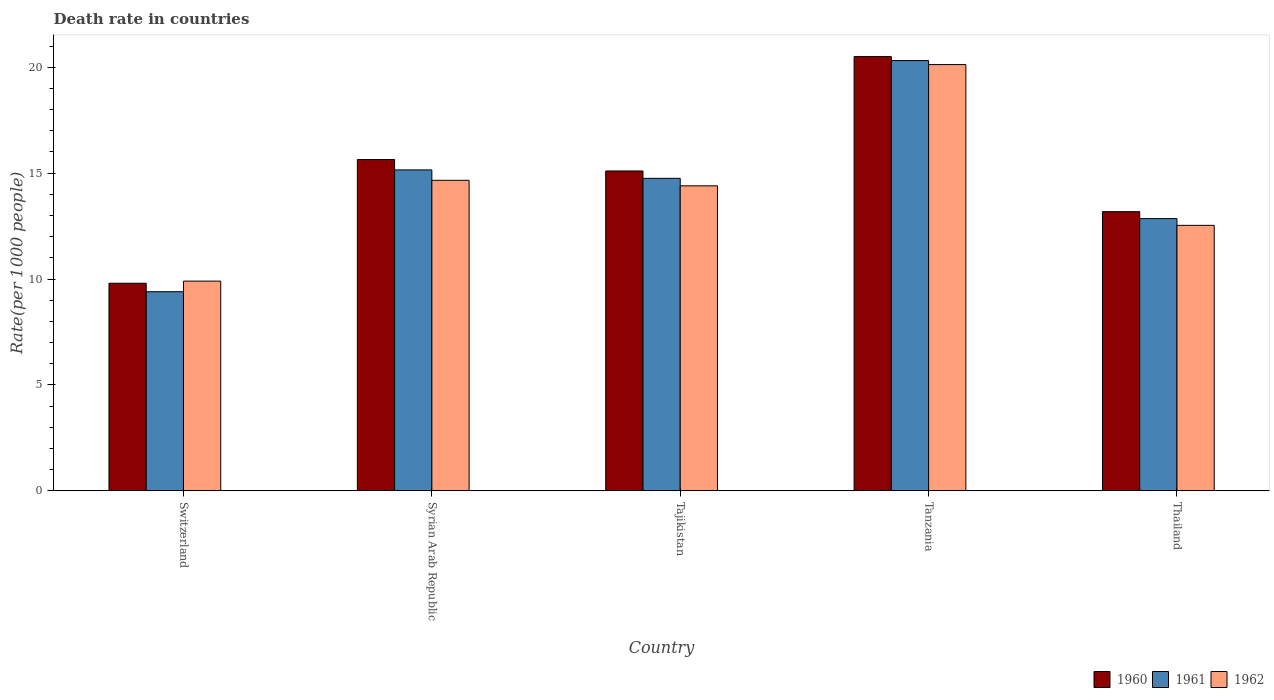How many different coloured bars are there?
Your response must be concise. 3. How many groups of bars are there?
Offer a terse response. 5. What is the label of the 2nd group of bars from the left?
Your answer should be compact. Syrian Arab Republic. What is the death rate in 1962 in Thailand?
Offer a terse response. 12.53. Across all countries, what is the maximum death rate in 1962?
Provide a short and direct response. 20.12. In which country was the death rate in 1960 maximum?
Offer a terse response. Tanzania. In which country was the death rate in 1960 minimum?
Keep it short and to the point. Switzerland. What is the total death rate in 1962 in the graph?
Provide a short and direct response. 71.62. What is the difference between the death rate in 1962 in Switzerland and that in Tanzania?
Your answer should be compact. -10.22. What is the difference between the death rate in 1960 in Syrian Arab Republic and the death rate in 1962 in Thailand?
Offer a very short reply. 3.11. What is the average death rate in 1960 per country?
Your answer should be compact. 14.84. What is the difference between the death rate of/in 1960 and death rate of/in 1961 in Tajikistan?
Provide a short and direct response. 0.35. In how many countries, is the death rate in 1961 greater than 16?
Your response must be concise. 1. What is the ratio of the death rate in 1961 in Switzerland to that in Tajikistan?
Provide a succinct answer. 0.64. Is the difference between the death rate in 1960 in Switzerland and Syrian Arab Republic greater than the difference between the death rate in 1961 in Switzerland and Syrian Arab Republic?
Your response must be concise. No. What is the difference between the highest and the second highest death rate in 1961?
Your answer should be compact. 5.56. What is the difference between the highest and the lowest death rate in 1961?
Offer a terse response. 10.91. Is the sum of the death rate in 1961 in Syrian Arab Republic and Tajikistan greater than the maximum death rate in 1962 across all countries?
Provide a short and direct response. Yes. What does the 2nd bar from the left in Syrian Arab Republic represents?
Make the answer very short. 1961. What does the 2nd bar from the right in Tanzania represents?
Offer a terse response. 1961. Is it the case that in every country, the sum of the death rate in 1960 and death rate in 1962 is greater than the death rate in 1961?
Give a very brief answer. Yes. Are all the bars in the graph horizontal?
Provide a succinct answer. No. How many countries are there in the graph?
Provide a short and direct response. 5. What is the difference between two consecutive major ticks on the Y-axis?
Give a very brief answer. 5. Does the graph contain any zero values?
Your answer should be very brief. No. Where does the legend appear in the graph?
Offer a very short reply. Bottom right. How many legend labels are there?
Ensure brevity in your answer.  3. What is the title of the graph?
Provide a short and direct response. Death rate in countries. What is the label or title of the X-axis?
Make the answer very short. Country. What is the label or title of the Y-axis?
Your answer should be very brief. Rate(per 1000 people). What is the Rate(per 1000 people) in 1961 in Switzerland?
Ensure brevity in your answer.  9.4. What is the Rate(per 1000 people) in 1960 in Syrian Arab Republic?
Ensure brevity in your answer.  15.64. What is the Rate(per 1000 people) of 1961 in Syrian Arab Republic?
Ensure brevity in your answer.  15.15. What is the Rate(per 1000 people) in 1962 in Syrian Arab Republic?
Your answer should be very brief. 14.66. What is the Rate(per 1000 people) of 1960 in Tajikistan?
Give a very brief answer. 15.1. What is the Rate(per 1000 people) in 1961 in Tajikistan?
Your answer should be compact. 14.75. What is the Rate(per 1000 people) in 1962 in Tajikistan?
Your response must be concise. 14.4. What is the Rate(per 1000 people) in 1960 in Tanzania?
Your response must be concise. 20.5. What is the Rate(per 1000 people) in 1961 in Tanzania?
Give a very brief answer. 20.31. What is the Rate(per 1000 people) in 1962 in Tanzania?
Give a very brief answer. 20.12. What is the Rate(per 1000 people) in 1960 in Thailand?
Give a very brief answer. 13.18. What is the Rate(per 1000 people) in 1961 in Thailand?
Your response must be concise. 12.85. What is the Rate(per 1000 people) in 1962 in Thailand?
Give a very brief answer. 12.53. Across all countries, what is the maximum Rate(per 1000 people) in 1960?
Ensure brevity in your answer.  20.5. Across all countries, what is the maximum Rate(per 1000 people) in 1961?
Provide a succinct answer. 20.31. Across all countries, what is the maximum Rate(per 1000 people) in 1962?
Make the answer very short. 20.12. Across all countries, what is the minimum Rate(per 1000 people) of 1961?
Your answer should be very brief. 9.4. Across all countries, what is the minimum Rate(per 1000 people) of 1962?
Provide a short and direct response. 9.9. What is the total Rate(per 1000 people) of 1960 in the graph?
Keep it short and to the point. 74.22. What is the total Rate(per 1000 people) of 1961 in the graph?
Your response must be concise. 72.47. What is the total Rate(per 1000 people) in 1962 in the graph?
Your answer should be compact. 71.62. What is the difference between the Rate(per 1000 people) of 1960 in Switzerland and that in Syrian Arab Republic?
Your answer should be very brief. -5.84. What is the difference between the Rate(per 1000 people) in 1961 in Switzerland and that in Syrian Arab Republic?
Your response must be concise. -5.75. What is the difference between the Rate(per 1000 people) of 1962 in Switzerland and that in Syrian Arab Republic?
Give a very brief answer. -4.76. What is the difference between the Rate(per 1000 people) in 1960 in Switzerland and that in Tajikistan?
Make the answer very short. -5.3. What is the difference between the Rate(per 1000 people) of 1961 in Switzerland and that in Tajikistan?
Ensure brevity in your answer.  -5.35. What is the difference between the Rate(per 1000 people) in 1962 in Switzerland and that in Tajikistan?
Give a very brief answer. -4.5. What is the difference between the Rate(per 1000 people) of 1960 in Switzerland and that in Tanzania?
Your answer should be compact. -10.7. What is the difference between the Rate(per 1000 people) of 1961 in Switzerland and that in Tanzania?
Make the answer very short. -10.91. What is the difference between the Rate(per 1000 people) of 1962 in Switzerland and that in Tanzania?
Your answer should be compact. -10.22. What is the difference between the Rate(per 1000 people) in 1960 in Switzerland and that in Thailand?
Offer a terse response. -3.38. What is the difference between the Rate(per 1000 people) in 1961 in Switzerland and that in Thailand?
Give a very brief answer. -3.45. What is the difference between the Rate(per 1000 people) in 1962 in Switzerland and that in Thailand?
Your answer should be very brief. -2.63. What is the difference between the Rate(per 1000 people) in 1960 in Syrian Arab Republic and that in Tajikistan?
Your answer should be very brief. 0.54. What is the difference between the Rate(per 1000 people) of 1961 in Syrian Arab Republic and that in Tajikistan?
Your response must be concise. 0.4. What is the difference between the Rate(per 1000 people) of 1962 in Syrian Arab Republic and that in Tajikistan?
Provide a short and direct response. 0.26. What is the difference between the Rate(per 1000 people) of 1960 in Syrian Arab Republic and that in Tanzania?
Your answer should be compact. -4.86. What is the difference between the Rate(per 1000 people) of 1961 in Syrian Arab Republic and that in Tanzania?
Your answer should be compact. -5.16. What is the difference between the Rate(per 1000 people) of 1962 in Syrian Arab Republic and that in Tanzania?
Make the answer very short. -5.46. What is the difference between the Rate(per 1000 people) of 1960 in Syrian Arab Republic and that in Thailand?
Your answer should be compact. 2.46. What is the difference between the Rate(per 1000 people) of 1961 in Syrian Arab Republic and that in Thailand?
Your answer should be very brief. 2.3. What is the difference between the Rate(per 1000 people) in 1962 in Syrian Arab Republic and that in Thailand?
Your response must be concise. 2.13. What is the difference between the Rate(per 1000 people) in 1960 in Tajikistan and that in Tanzania?
Your answer should be compact. -5.4. What is the difference between the Rate(per 1000 people) of 1961 in Tajikistan and that in Tanzania?
Your answer should be compact. -5.56. What is the difference between the Rate(per 1000 people) of 1962 in Tajikistan and that in Tanzania?
Keep it short and to the point. -5.73. What is the difference between the Rate(per 1000 people) in 1960 in Tajikistan and that in Thailand?
Make the answer very short. 1.92. What is the difference between the Rate(per 1000 people) in 1961 in Tajikistan and that in Thailand?
Make the answer very short. 1.9. What is the difference between the Rate(per 1000 people) of 1962 in Tajikistan and that in Thailand?
Offer a terse response. 1.87. What is the difference between the Rate(per 1000 people) in 1960 in Tanzania and that in Thailand?
Offer a terse response. 7.32. What is the difference between the Rate(per 1000 people) in 1961 in Tanzania and that in Thailand?
Your response must be concise. 7.46. What is the difference between the Rate(per 1000 people) in 1962 in Tanzania and that in Thailand?
Your response must be concise. 7.59. What is the difference between the Rate(per 1000 people) of 1960 in Switzerland and the Rate(per 1000 people) of 1961 in Syrian Arab Republic?
Provide a succinct answer. -5.35. What is the difference between the Rate(per 1000 people) in 1960 in Switzerland and the Rate(per 1000 people) in 1962 in Syrian Arab Republic?
Your response must be concise. -4.86. What is the difference between the Rate(per 1000 people) of 1961 in Switzerland and the Rate(per 1000 people) of 1962 in Syrian Arab Republic?
Offer a very short reply. -5.26. What is the difference between the Rate(per 1000 people) of 1960 in Switzerland and the Rate(per 1000 people) of 1961 in Tajikistan?
Your answer should be very brief. -4.95. What is the difference between the Rate(per 1000 people) of 1960 in Switzerland and the Rate(per 1000 people) of 1962 in Tajikistan?
Give a very brief answer. -4.6. What is the difference between the Rate(per 1000 people) of 1961 in Switzerland and the Rate(per 1000 people) of 1962 in Tajikistan?
Provide a succinct answer. -5. What is the difference between the Rate(per 1000 people) of 1960 in Switzerland and the Rate(per 1000 people) of 1961 in Tanzania?
Offer a very short reply. -10.51. What is the difference between the Rate(per 1000 people) of 1960 in Switzerland and the Rate(per 1000 people) of 1962 in Tanzania?
Offer a very short reply. -10.32. What is the difference between the Rate(per 1000 people) in 1961 in Switzerland and the Rate(per 1000 people) in 1962 in Tanzania?
Provide a succinct answer. -10.72. What is the difference between the Rate(per 1000 people) of 1960 in Switzerland and the Rate(per 1000 people) of 1961 in Thailand?
Keep it short and to the point. -3.05. What is the difference between the Rate(per 1000 people) of 1960 in Switzerland and the Rate(per 1000 people) of 1962 in Thailand?
Your response must be concise. -2.73. What is the difference between the Rate(per 1000 people) in 1961 in Switzerland and the Rate(per 1000 people) in 1962 in Thailand?
Offer a terse response. -3.13. What is the difference between the Rate(per 1000 people) of 1960 in Syrian Arab Republic and the Rate(per 1000 people) of 1961 in Tajikistan?
Keep it short and to the point. 0.89. What is the difference between the Rate(per 1000 people) in 1960 in Syrian Arab Republic and the Rate(per 1000 people) in 1962 in Tajikistan?
Give a very brief answer. 1.24. What is the difference between the Rate(per 1000 people) in 1961 in Syrian Arab Republic and the Rate(per 1000 people) in 1962 in Tajikistan?
Provide a succinct answer. 0.75. What is the difference between the Rate(per 1000 people) in 1960 in Syrian Arab Republic and the Rate(per 1000 people) in 1961 in Tanzania?
Your answer should be very brief. -4.67. What is the difference between the Rate(per 1000 people) of 1960 in Syrian Arab Republic and the Rate(per 1000 people) of 1962 in Tanzania?
Provide a short and direct response. -4.48. What is the difference between the Rate(per 1000 people) in 1961 in Syrian Arab Republic and the Rate(per 1000 people) in 1962 in Tanzania?
Make the answer very short. -4.97. What is the difference between the Rate(per 1000 people) of 1960 in Syrian Arab Republic and the Rate(per 1000 people) of 1961 in Thailand?
Ensure brevity in your answer.  2.79. What is the difference between the Rate(per 1000 people) of 1960 in Syrian Arab Republic and the Rate(per 1000 people) of 1962 in Thailand?
Your answer should be very brief. 3.11. What is the difference between the Rate(per 1000 people) in 1961 in Syrian Arab Republic and the Rate(per 1000 people) in 1962 in Thailand?
Your answer should be compact. 2.62. What is the difference between the Rate(per 1000 people) of 1960 in Tajikistan and the Rate(per 1000 people) of 1961 in Tanzania?
Give a very brief answer. -5.21. What is the difference between the Rate(per 1000 people) in 1960 in Tajikistan and the Rate(per 1000 people) in 1962 in Tanzania?
Keep it short and to the point. -5.02. What is the difference between the Rate(per 1000 people) in 1961 in Tajikistan and the Rate(per 1000 people) in 1962 in Tanzania?
Offer a very short reply. -5.37. What is the difference between the Rate(per 1000 people) of 1960 in Tajikistan and the Rate(per 1000 people) of 1961 in Thailand?
Make the answer very short. 2.25. What is the difference between the Rate(per 1000 people) of 1960 in Tajikistan and the Rate(per 1000 people) of 1962 in Thailand?
Offer a terse response. 2.57. What is the difference between the Rate(per 1000 people) of 1961 in Tajikistan and the Rate(per 1000 people) of 1962 in Thailand?
Your answer should be compact. 2.22. What is the difference between the Rate(per 1000 people) in 1960 in Tanzania and the Rate(per 1000 people) in 1961 in Thailand?
Your response must be concise. 7.65. What is the difference between the Rate(per 1000 people) of 1960 in Tanzania and the Rate(per 1000 people) of 1962 in Thailand?
Give a very brief answer. 7.97. What is the difference between the Rate(per 1000 people) in 1961 in Tanzania and the Rate(per 1000 people) in 1962 in Thailand?
Offer a terse response. 7.78. What is the average Rate(per 1000 people) in 1960 per country?
Your response must be concise. 14.84. What is the average Rate(per 1000 people) in 1961 per country?
Your answer should be compact. 14.49. What is the average Rate(per 1000 people) in 1962 per country?
Make the answer very short. 14.32. What is the difference between the Rate(per 1000 people) of 1960 and Rate(per 1000 people) of 1962 in Switzerland?
Your answer should be very brief. -0.1. What is the difference between the Rate(per 1000 people) of 1960 and Rate(per 1000 people) of 1961 in Syrian Arab Republic?
Ensure brevity in your answer.  0.49. What is the difference between the Rate(per 1000 people) of 1960 and Rate(per 1000 people) of 1962 in Syrian Arab Republic?
Ensure brevity in your answer.  0.98. What is the difference between the Rate(per 1000 people) of 1961 and Rate(per 1000 people) of 1962 in Syrian Arab Republic?
Provide a succinct answer. 0.49. What is the difference between the Rate(per 1000 people) of 1960 and Rate(per 1000 people) of 1961 in Tajikistan?
Keep it short and to the point. 0.35. What is the difference between the Rate(per 1000 people) in 1960 and Rate(per 1000 people) in 1962 in Tajikistan?
Make the answer very short. 0.7. What is the difference between the Rate(per 1000 people) of 1961 and Rate(per 1000 people) of 1962 in Tajikistan?
Give a very brief answer. 0.35. What is the difference between the Rate(per 1000 people) of 1960 and Rate(per 1000 people) of 1961 in Tanzania?
Your answer should be compact. 0.19. What is the difference between the Rate(per 1000 people) of 1960 and Rate(per 1000 people) of 1962 in Tanzania?
Ensure brevity in your answer.  0.38. What is the difference between the Rate(per 1000 people) of 1961 and Rate(per 1000 people) of 1962 in Tanzania?
Offer a very short reply. 0.19. What is the difference between the Rate(per 1000 people) in 1960 and Rate(per 1000 people) in 1961 in Thailand?
Your response must be concise. 0.33. What is the difference between the Rate(per 1000 people) of 1960 and Rate(per 1000 people) of 1962 in Thailand?
Your answer should be very brief. 0.65. What is the difference between the Rate(per 1000 people) in 1961 and Rate(per 1000 people) in 1962 in Thailand?
Make the answer very short. 0.32. What is the ratio of the Rate(per 1000 people) in 1960 in Switzerland to that in Syrian Arab Republic?
Give a very brief answer. 0.63. What is the ratio of the Rate(per 1000 people) in 1961 in Switzerland to that in Syrian Arab Republic?
Your answer should be compact. 0.62. What is the ratio of the Rate(per 1000 people) in 1962 in Switzerland to that in Syrian Arab Republic?
Your answer should be compact. 0.68. What is the ratio of the Rate(per 1000 people) in 1960 in Switzerland to that in Tajikistan?
Ensure brevity in your answer.  0.65. What is the ratio of the Rate(per 1000 people) in 1961 in Switzerland to that in Tajikistan?
Offer a terse response. 0.64. What is the ratio of the Rate(per 1000 people) of 1962 in Switzerland to that in Tajikistan?
Your response must be concise. 0.69. What is the ratio of the Rate(per 1000 people) in 1960 in Switzerland to that in Tanzania?
Give a very brief answer. 0.48. What is the ratio of the Rate(per 1000 people) of 1961 in Switzerland to that in Tanzania?
Your answer should be compact. 0.46. What is the ratio of the Rate(per 1000 people) of 1962 in Switzerland to that in Tanzania?
Ensure brevity in your answer.  0.49. What is the ratio of the Rate(per 1000 people) of 1960 in Switzerland to that in Thailand?
Offer a very short reply. 0.74. What is the ratio of the Rate(per 1000 people) of 1961 in Switzerland to that in Thailand?
Keep it short and to the point. 0.73. What is the ratio of the Rate(per 1000 people) in 1962 in Switzerland to that in Thailand?
Give a very brief answer. 0.79. What is the ratio of the Rate(per 1000 people) of 1960 in Syrian Arab Republic to that in Tajikistan?
Make the answer very short. 1.04. What is the ratio of the Rate(per 1000 people) in 1961 in Syrian Arab Republic to that in Tajikistan?
Provide a short and direct response. 1.03. What is the ratio of the Rate(per 1000 people) of 1962 in Syrian Arab Republic to that in Tajikistan?
Offer a very short reply. 1.02. What is the ratio of the Rate(per 1000 people) of 1960 in Syrian Arab Republic to that in Tanzania?
Ensure brevity in your answer.  0.76. What is the ratio of the Rate(per 1000 people) in 1961 in Syrian Arab Republic to that in Tanzania?
Give a very brief answer. 0.75. What is the ratio of the Rate(per 1000 people) of 1962 in Syrian Arab Republic to that in Tanzania?
Offer a very short reply. 0.73. What is the ratio of the Rate(per 1000 people) in 1960 in Syrian Arab Republic to that in Thailand?
Provide a short and direct response. 1.19. What is the ratio of the Rate(per 1000 people) in 1961 in Syrian Arab Republic to that in Thailand?
Your answer should be very brief. 1.18. What is the ratio of the Rate(per 1000 people) of 1962 in Syrian Arab Republic to that in Thailand?
Keep it short and to the point. 1.17. What is the ratio of the Rate(per 1000 people) of 1960 in Tajikistan to that in Tanzania?
Your answer should be very brief. 0.74. What is the ratio of the Rate(per 1000 people) in 1961 in Tajikistan to that in Tanzania?
Offer a terse response. 0.73. What is the ratio of the Rate(per 1000 people) in 1962 in Tajikistan to that in Tanzania?
Your response must be concise. 0.72. What is the ratio of the Rate(per 1000 people) in 1960 in Tajikistan to that in Thailand?
Offer a very short reply. 1.15. What is the ratio of the Rate(per 1000 people) of 1961 in Tajikistan to that in Thailand?
Provide a succinct answer. 1.15. What is the ratio of the Rate(per 1000 people) of 1962 in Tajikistan to that in Thailand?
Provide a short and direct response. 1.15. What is the ratio of the Rate(per 1000 people) in 1960 in Tanzania to that in Thailand?
Provide a succinct answer. 1.56. What is the ratio of the Rate(per 1000 people) in 1961 in Tanzania to that in Thailand?
Provide a short and direct response. 1.58. What is the ratio of the Rate(per 1000 people) of 1962 in Tanzania to that in Thailand?
Your answer should be very brief. 1.61. What is the difference between the highest and the second highest Rate(per 1000 people) of 1960?
Provide a succinct answer. 4.86. What is the difference between the highest and the second highest Rate(per 1000 people) of 1961?
Your response must be concise. 5.16. What is the difference between the highest and the second highest Rate(per 1000 people) in 1962?
Keep it short and to the point. 5.46. What is the difference between the highest and the lowest Rate(per 1000 people) of 1960?
Your response must be concise. 10.7. What is the difference between the highest and the lowest Rate(per 1000 people) of 1961?
Make the answer very short. 10.91. What is the difference between the highest and the lowest Rate(per 1000 people) of 1962?
Ensure brevity in your answer.  10.22. 